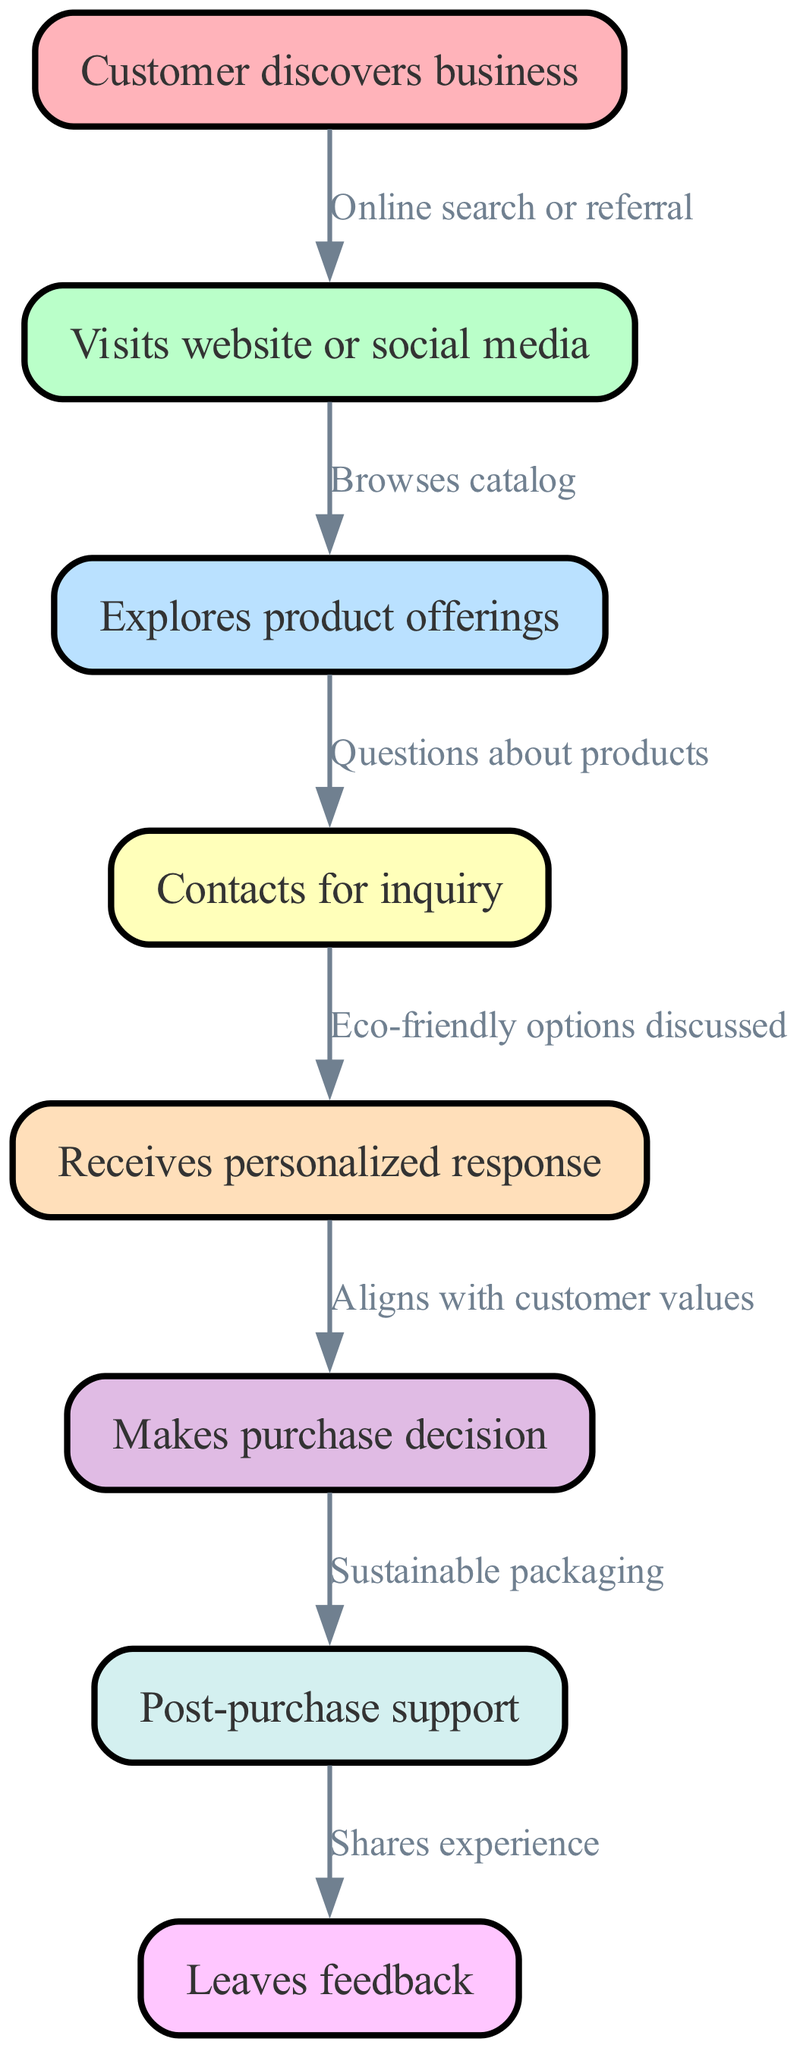What is the first step in the customer journey? The first node in the flowchart is labeled "Customer discovers business," which indicates that this is the initial step customers take in the journey.
Answer: Customer discovers business How many nodes are present in the diagram? By counting the nodes listed in the data, we find there are a total of 8 different nodes in the customer journey flowchart.
Answer: 8 What is the relationship between node "Contacts for inquiry" and node "Receives personalized response"? There is a direct edge connecting node "4" (Contacts for inquiry) to node "5" (Receives personalized response), indicating that contacting the business results in receiving a personalized response.
Answer: Eco-friendly options discussed What touchpoint follows "Makes purchase decision"? The diagram shows that after the node "Makes purchase decision," the next step is "Post-purchase support," indicating that customers receive support after they decide to purchase.
Answer: Post-purchase support What describes the connection from "Explores product offerings" to "Contacts for inquiry"? The edge connecting these two nodes indicates that customers ask "Questions about products," which suggests that exploring available offerings often leads to inquiries.
Answer: Questions about products If a customer leaves feedback, what step preceded it in the flow? According to the flowchart, the last step before leaving feedback is the "Post-purchase support," meaning that feedback is typically shared after customers receive assistance post-purchase.
Answer: Post-purchase support What type of response is indicated during the inquiry stage? During the inquiry stage, customers receive a "personalized response," which emphasizes the business's commitment to tailoring their communication to fit customer needs.
Answer: Personalized response Which node reflects the importance of customer values in purchasing? The flowchart explicitly states that after receiving a personalized response, customers "Aligns with customer values" in their decision-making process, highlighting the significance of values in their purchases.
Answer: Aligns with customer values 